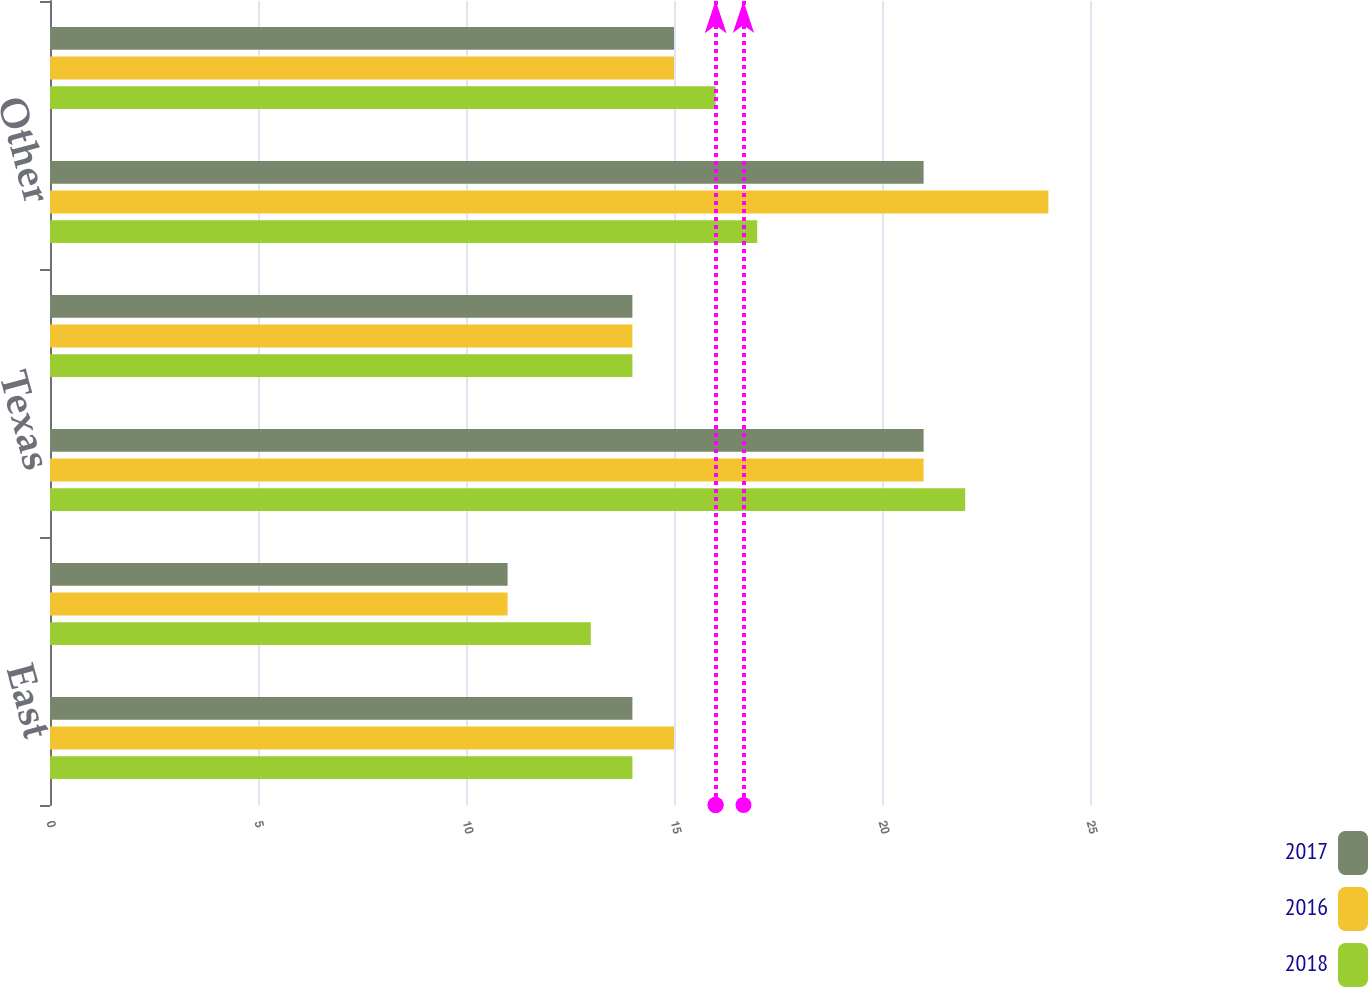<chart> <loc_0><loc_0><loc_500><loc_500><stacked_bar_chart><ecel><fcel>East<fcel>Central<fcel>Texas<fcel>West<fcel>Other<fcel>Total<nl><fcel>2017<fcel>14<fcel>11<fcel>21<fcel>14<fcel>21<fcel>15<nl><fcel>2016<fcel>15<fcel>11<fcel>21<fcel>14<fcel>24<fcel>15<nl><fcel>2018<fcel>14<fcel>13<fcel>22<fcel>14<fcel>17<fcel>16<nl></chart> 